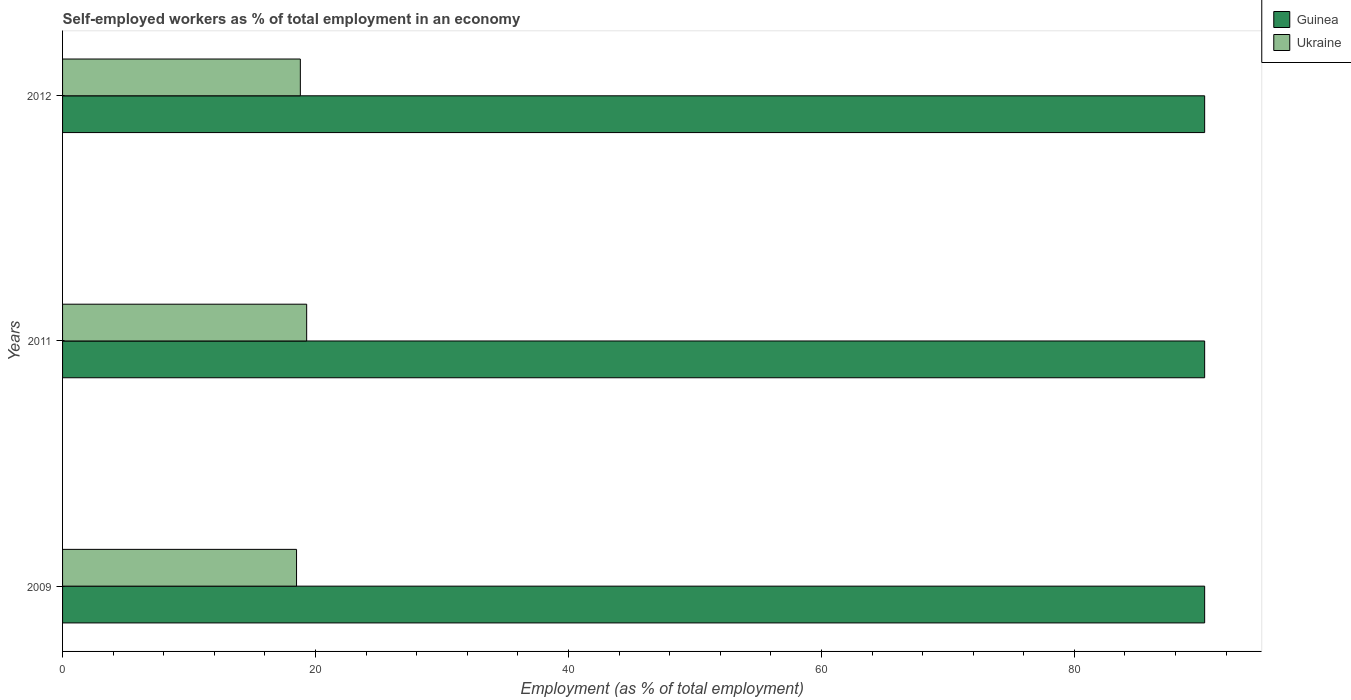How many different coloured bars are there?
Make the answer very short. 2. Are the number of bars per tick equal to the number of legend labels?
Ensure brevity in your answer.  Yes. What is the label of the 3rd group of bars from the top?
Ensure brevity in your answer.  2009. In how many cases, is the number of bars for a given year not equal to the number of legend labels?
Your answer should be compact. 0. What is the percentage of self-employed workers in Guinea in 2009?
Your answer should be compact. 90.3. Across all years, what is the maximum percentage of self-employed workers in Ukraine?
Make the answer very short. 19.3. Across all years, what is the minimum percentage of self-employed workers in Guinea?
Offer a terse response. 90.3. In which year was the percentage of self-employed workers in Guinea minimum?
Ensure brevity in your answer.  2009. What is the total percentage of self-employed workers in Guinea in the graph?
Make the answer very short. 270.9. What is the difference between the percentage of self-employed workers in Guinea in 2009 and that in 2011?
Your answer should be compact. 0. What is the difference between the percentage of self-employed workers in Ukraine in 2009 and the percentage of self-employed workers in Guinea in 2012?
Ensure brevity in your answer.  -71.8. What is the average percentage of self-employed workers in Guinea per year?
Make the answer very short. 90.3. In the year 2009, what is the difference between the percentage of self-employed workers in Guinea and percentage of self-employed workers in Ukraine?
Keep it short and to the point. 71.8. Is the difference between the percentage of self-employed workers in Guinea in 2011 and 2012 greater than the difference between the percentage of self-employed workers in Ukraine in 2011 and 2012?
Ensure brevity in your answer.  No. What is the difference between the highest and the lowest percentage of self-employed workers in Ukraine?
Your answer should be compact. 0.8. Is the sum of the percentage of self-employed workers in Ukraine in 2011 and 2012 greater than the maximum percentage of self-employed workers in Guinea across all years?
Ensure brevity in your answer.  No. What does the 1st bar from the top in 2009 represents?
Give a very brief answer. Ukraine. What does the 1st bar from the bottom in 2009 represents?
Offer a terse response. Guinea. How many bars are there?
Offer a terse response. 6. Are all the bars in the graph horizontal?
Keep it short and to the point. Yes. What is the difference between two consecutive major ticks on the X-axis?
Your response must be concise. 20. Are the values on the major ticks of X-axis written in scientific E-notation?
Offer a terse response. No. Does the graph contain any zero values?
Make the answer very short. No. Where does the legend appear in the graph?
Keep it short and to the point. Top right. What is the title of the graph?
Provide a short and direct response. Self-employed workers as % of total employment in an economy. What is the label or title of the X-axis?
Your answer should be compact. Employment (as % of total employment). What is the label or title of the Y-axis?
Give a very brief answer. Years. What is the Employment (as % of total employment) in Guinea in 2009?
Provide a succinct answer. 90.3. What is the Employment (as % of total employment) of Ukraine in 2009?
Offer a terse response. 18.5. What is the Employment (as % of total employment) in Guinea in 2011?
Offer a terse response. 90.3. What is the Employment (as % of total employment) of Ukraine in 2011?
Make the answer very short. 19.3. What is the Employment (as % of total employment) in Guinea in 2012?
Offer a terse response. 90.3. What is the Employment (as % of total employment) in Ukraine in 2012?
Ensure brevity in your answer.  18.8. Across all years, what is the maximum Employment (as % of total employment) of Guinea?
Provide a short and direct response. 90.3. Across all years, what is the maximum Employment (as % of total employment) in Ukraine?
Give a very brief answer. 19.3. Across all years, what is the minimum Employment (as % of total employment) of Guinea?
Your answer should be compact. 90.3. Across all years, what is the minimum Employment (as % of total employment) in Ukraine?
Ensure brevity in your answer.  18.5. What is the total Employment (as % of total employment) of Guinea in the graph?
Make the answer very short. 270.9. What is the total Employment (as % of total employment) in Ukraine in the graph?
Keep it short and to the point. 56.6. What is the difference between the Employment (as % of total employment) of Ukraine in 2009 and that in 2011?
Provide a succinct answer. -0.8. What is the difference between the Employment (as % of total employment) in Guinea in 2011 and that in 2012?
Give a very brief answer. 0. What is the difference between the Employment (as % of total employment) in Guinea in 2009 and the Employment (as % of total employment) in Ukraine in 2012?
Make the answer very short. 71.5. What is the difference between the Employment (as % of total employment) of Guinea in 2011 and the Employment (as % of total employment) of Ukraine in 2012?
Provide a short and direct response. 71.5. What is the average Employment (as % of total employment) in Guinea per year?
Offer a very short reply. 90.3. What is the average Employment (as % of total employment) in Ukraine per year?
Keep it short and to the point. 18.87. In the year 2009, what is the difference between the Employment (as % of total employment) in Guinea and Employment (as % of total employment) in Ukraine?
Your answer should be compact. 71.8. In the year 2011, what is the difference between the Employment (as % of total employment) of Guinea and Employment (as % of total employment) of Ukraine?
Give a very brief answer. 71. In the year 2012, what is the difference between the Employment (as % of total employment) of Guinea and Employment (as % of total employment) of Ukraine?
Keep it short and to the point. 71.5. What is the ratio of the Employment (as % of total employment) of Ukraine in 2009 to that in 2011?
Your response must be concise. 0.96. What is the ratio of the Employment (as % of total employment) in Guinea in 2009 to that in 2012?
Your response must be concise. 1. What is the ratio of the Employment (as % of total employment) of Ukraine in 2009 to that in 2012?
Your answer should be compact. 0.98. What is the ratio of the Employment (as % of total employment) of Guinea in 2011 to that in 2012?
Make the answer very short. 1. What is the ratio of the Employment (as % of total employment) of Ukraine in 2011 to that in 2012?
Your answer should be compact. 1.03. What is the difference between the highest and the second highest Employment (as % of total employment) in Guinea?
Ensure brevity in your answer.  0. What is the difference between the highest and the lowest Employment (as % of total employment) of Guinea?
Offer a very short reply. 0. What is the difference between the highest and the lowest Employment (as % of total employment) in Ukraine?
Provide a short and direct response. 0.8. 